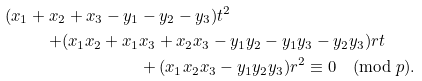Convert formula to latex. <formula><loc_0><loc_0><loc_500><loc_500>( x _ { 1 } + x _ { 2 } + x _ { 3 } - y _ { 1 } & - y _ { 2 } - y _ { 3 } ) t ^ { 2 } \\ + ( x _ { 1 } x _ { 2 } + x _ { 1 } & x _ { 3 } + x _ { 2 } x _ { 3 } - y _ { 1 } y _ { 2 } - y _ { 1 } y _ { 3 } - y _ { 2 } y _ { 3 } ) r t \\ & + ( x _ { 1 } x _ { 2 } x _ { 3 } - y _ { 1 } y _ { 2 } y _ { 3 } ) r ^ { 2 } \equiv 0 \pmod { p } .</formula> 